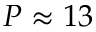Convert formula to latex. <formula><loc_0><loc_0><loc_500><loc_500>P \approx 1 3</formula> 